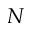<formula> <loc_0><loc_0><loc_500><loc_500>N</formula> 